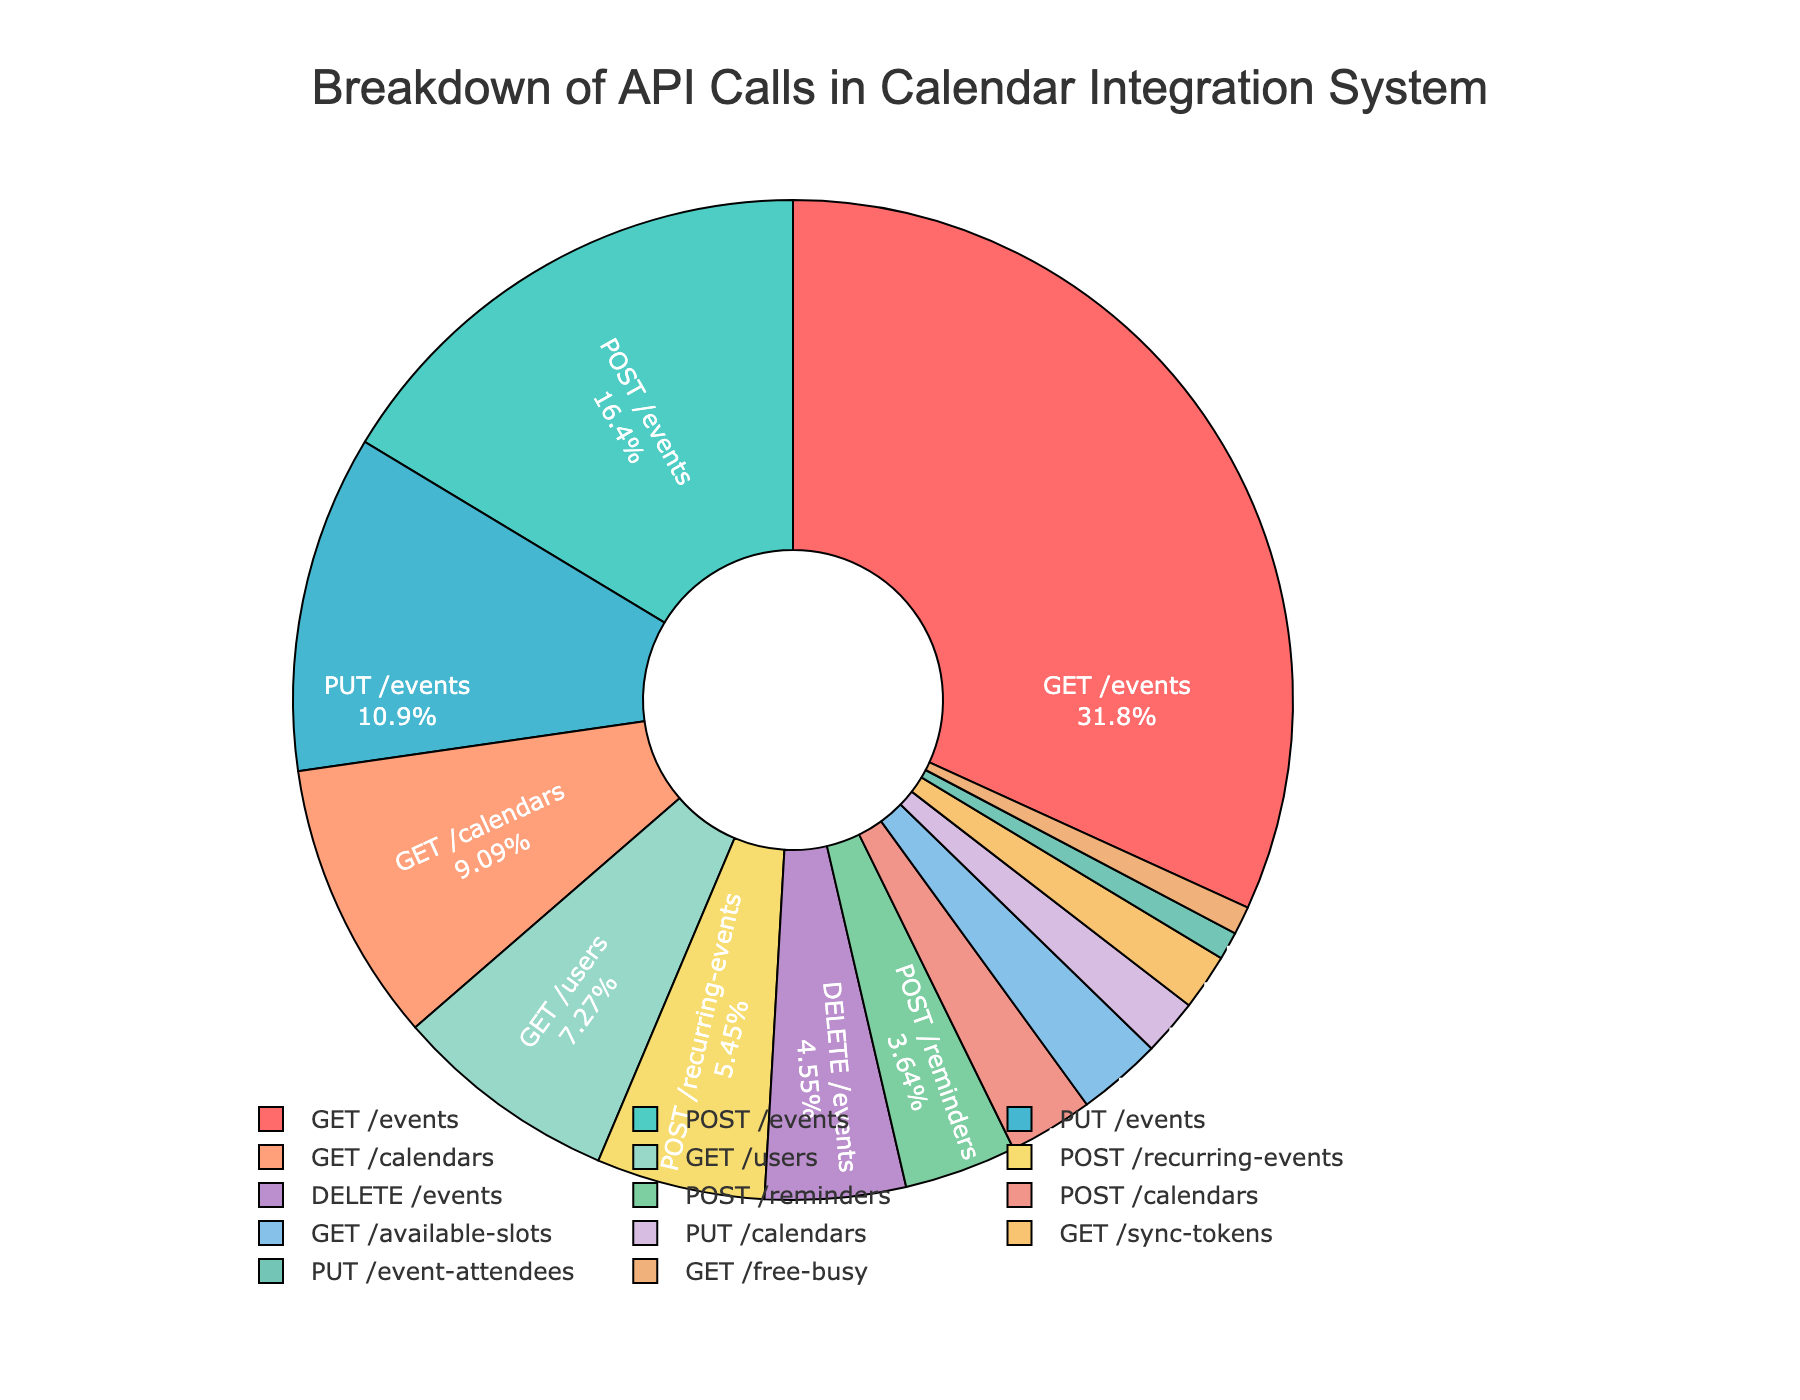Which API endpoint has the highest percentage of calls? By observing the pie chart, the segment representing "GET /events" is the largest with 35% of the calls.
Answer: GET /events What is the total percentage of "GET" requests made to the calendar integration system? Adding up the percentages for "GET /events" (35%), "GET /calendars" (10%), "GET /users" (8%), "GET /available-slots" (3%), "GET /sync-tokens" (2%), and "GET /free-busy" (1%) gives 35 + 10 + 8 + 3 + 2 + 1 = 59%.
Answer: 59% Which method (GET, POST, PUT, DELETE) has the least percentage of API calls, and what's its percentage? Observing the visual representation, "DELETE /events" has the smallest individual segment. Summing up all methods: GET=59%, POST=31%, PUT=15%, DELETE=5%. The least percentage is DELETE with 5%.
Answer: DELETE, 5% What is the combined percentage of the "POST /events" and "POST /calendars" API calls? The pie chart shows "POST /events" as 18% and "POST /calendars" as 3%. Adding these values results in 18 + 3 = 21%.
Answer: 21% What percentage of API calls are related to managing events (GET, POST, PUT, DELETE /events)? Summing the percentages for all event-related API calls: GET /events (35%), POST /events (18%), PUT /events (12%), DELETE /events (5%) gives 35 + 18 + 12 + 5 = 70%.
Answer: 70% How does the percentage of "GET /calendars" compare to "POST /recurring-events"? The "GET /calendars" has a 10% share, while "POST /recurring-events" accounts for 6%. Therefore, "GET /calendars" has a higher percentage of API calls than "POST /recurring-events".
Answer: GET /calendars is higher Which category (events, calendars, users, reminders, available slots, sync tokens, event attendees, free busy) accounts for the smallest percentage, and what is it? From the pie chart, we see "PUT /event-attendees" and "GET /free-busy" each have the smallest segments with 1%.
Answer: event attendees, free busy, 1% What is the difference in percentage between "GET /events" and "POST /events"? By subtracting the percentage of "POST /events" (18%) from "GET /events" (35%), the difference is 35 - 18 = 17%.
Answer: 17% 